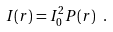Convert formula to latex. <formula><loc_0><loc_0><loc_500><loc_500>I ( r ) = I _ { 0 } ^ { 2 } P ( r ) \ .</formula> 